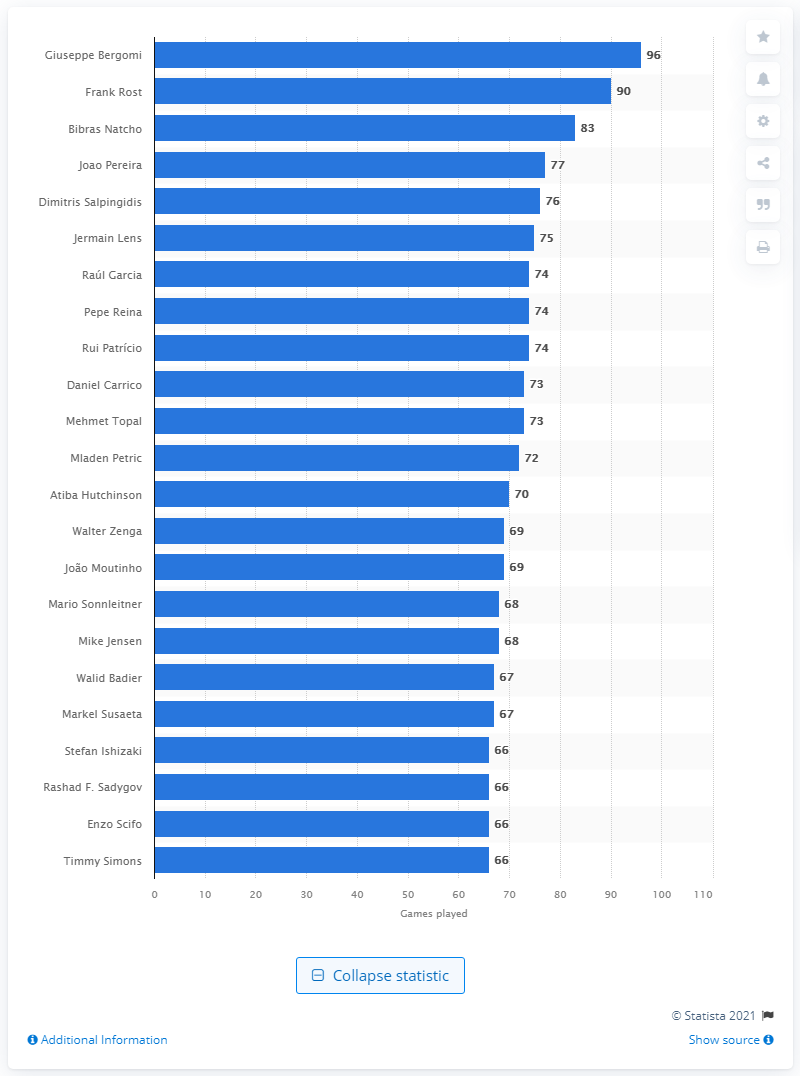List a handful of essential elements in this visual. The Italian footballer Giuseppe Bergomi holds the record for the most matches played in the UEFA Europa League. Giuseppe Bergomi has played a total of 96 games in the UEFA Europa League. Frank Rost holds the record for the most games played in the UEFA Europa League. 